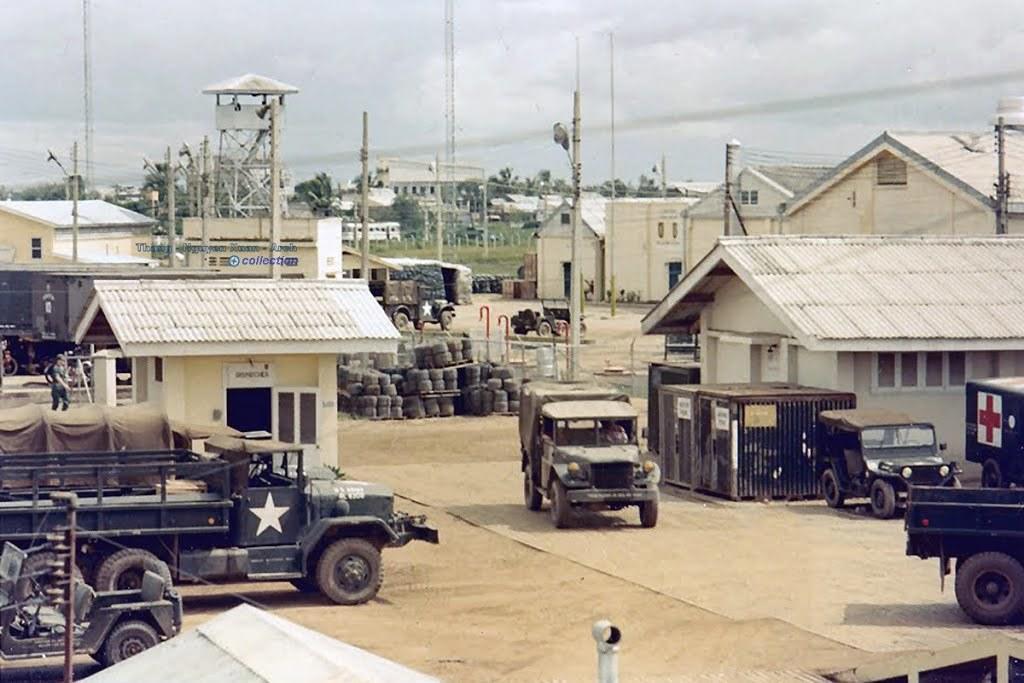Could you give a brief overview of what you see in this image? In the image there are few trucks going on the road and there are homes all over the image with electric poles in front of it and in the background there are trees and above its sky. 